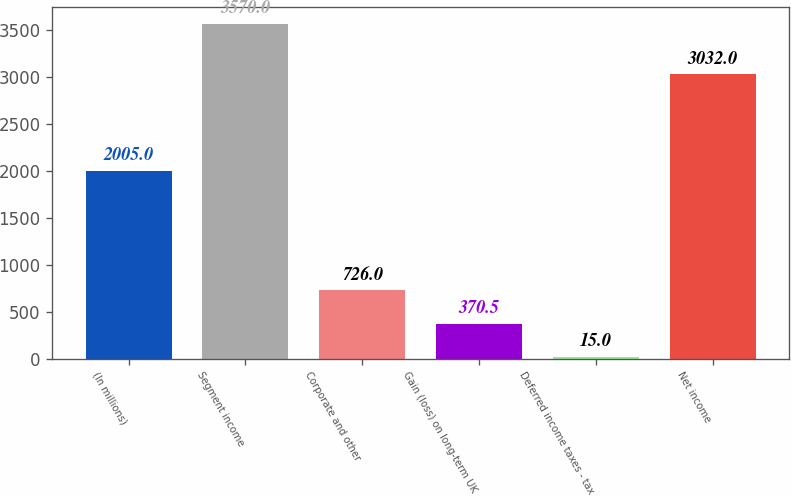Convert chart. <chart><loc_0><loc_0><loc_500><loc_500><bar_chart><fcel>(In millions)<fcel>Segment income<fcel>Corporate and other<fcel>Gain (loss) on long-term UK<fcel>Deferred income taxes - tax<fcel>Net income<nl><fcel>2005<fcel>3570<fcel>726<fcel>370.5<fcel>15<fcel>3032<nl></chart> 